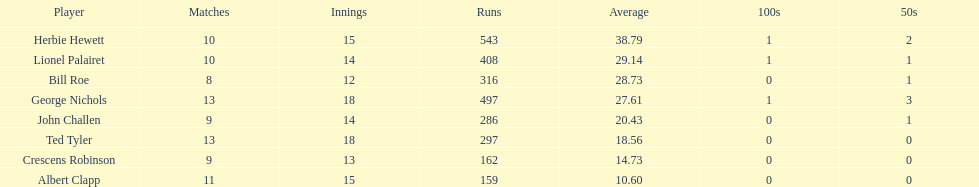Name a player that play in no more than 13 innings. Bill Roe. 